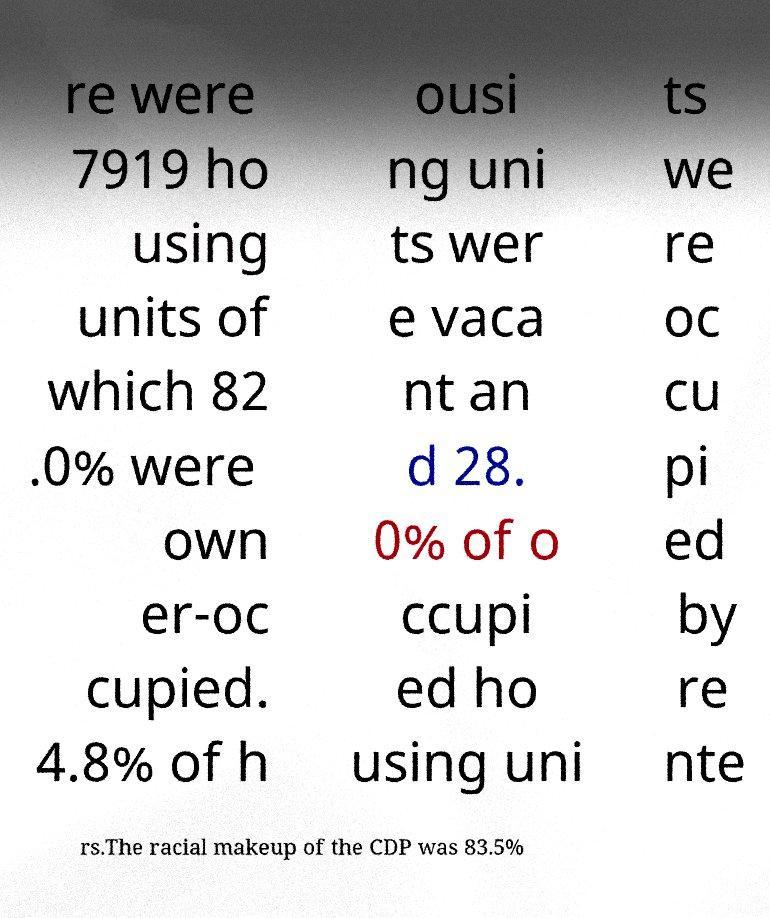I need the written content from this picture converted into text. Can you do that? re were 7919 ho using units of which 82 .0% were own er-oc cupied. 4.8% of h ousi ng uni ts wer e vaca nt an d 28. 0% of o ccupi ed ho using uni ts we re oc cu pi ed by re nte rs.The racial makeup of the CDP was 83.5% 